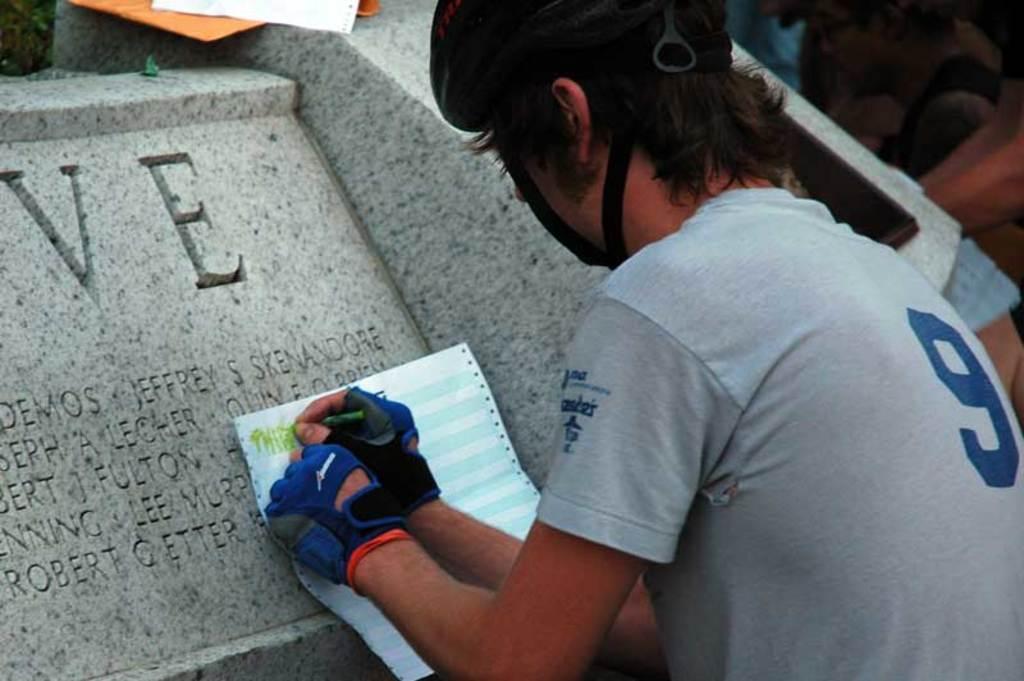Can you describe this image briefly? In this image, there are a few people. Among them, we can see a person holding an object. We can see some stones with text. We can also see some objects at the top.. 